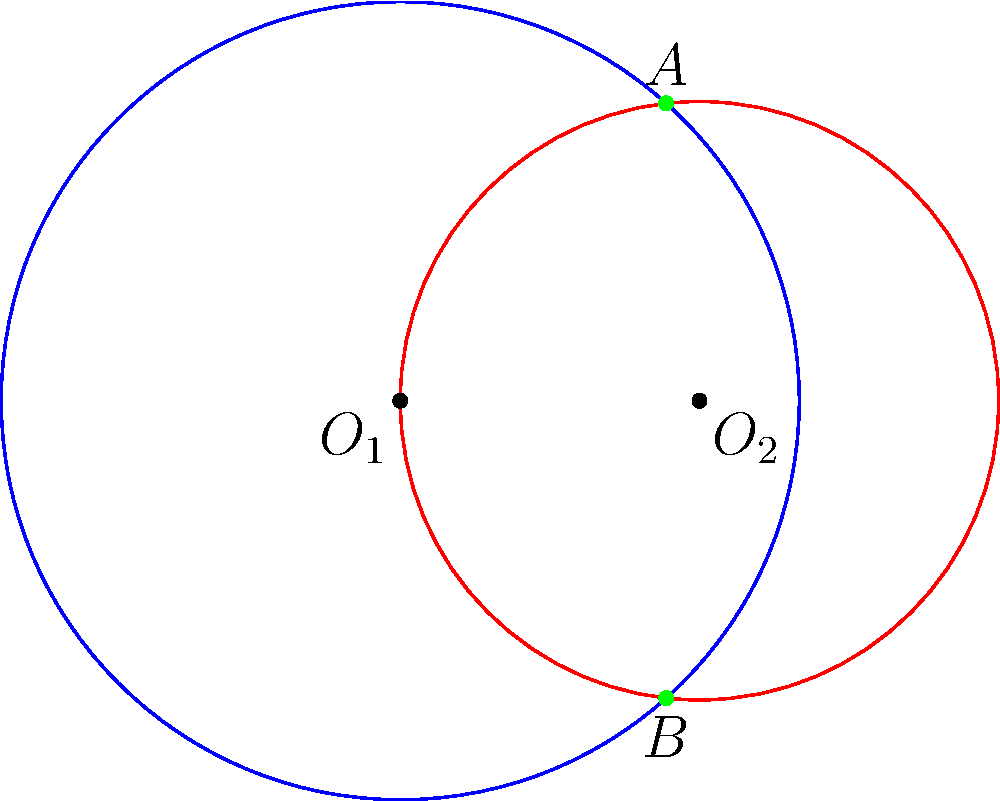As a songwriter inspired by Lady Gaga's innovative sound, you're exploring the concept of overlapping sound waves. Two circular sound waves are represented by the equations $(x^2 + y^2 = 16)$ and $((x-3)^2 + y^2 = 9)$. Find the coordinates of the intersection points A and B, which represent the points where these sound waves combine to create a unique resonance in your potential hit song. Let's approach this step-by-step:

1) The equations of the two circles are:
   Circle 1: $x^2 + y^2 = 16$ (centered at (0,0) with radius 4)
   Circle 2: $(x-3)^2 + y^2 = 9$ (centered at (3,0) with radius 3)

2) To find the intersection points, we need to solve these equations simultaneously.

3) Expand the second equation:
   $x^2 - 6x + 9 + y^2 = 9$
   $x^2 - 6x + y^2 = 0$

4) Subtract the second equation from the first:
   $x^2 + y^2 = 16$
   $x^2 - 6x + y^2 = 0$
   $6x = 16$
   $x = \frac{8}{3}$

5) Substitute this x-value into the first equation:
   $(\frac{8}{3})^2 + y^2 = 16$
   $\frac{64}{9} + y^2 = 16$
   $y^2 = 16 - \frac{64}{9} = \frac{144-64}{9} = \frac{80}{9}$
   $y = \pm \frac{2\sqrt{5}}{3}$

6) Therefore, the intersection points are:
   $A(\frac{8}{3}, \frac{2\sqrt{5}}{3})$ and $B(\frac{8}{3}, -\frac{2\sqrt{5}}{3})$

These points represent where the sound waves overlap, creating a unique resonance in your Lady Gaga-inspired composition.
Answer: $A(\frac{8}{3}, \frac{2\sqrt{5}}{3})$ and $B(\frac{8}{3}, -\frac{2\sqrt{5}}{3})$ 